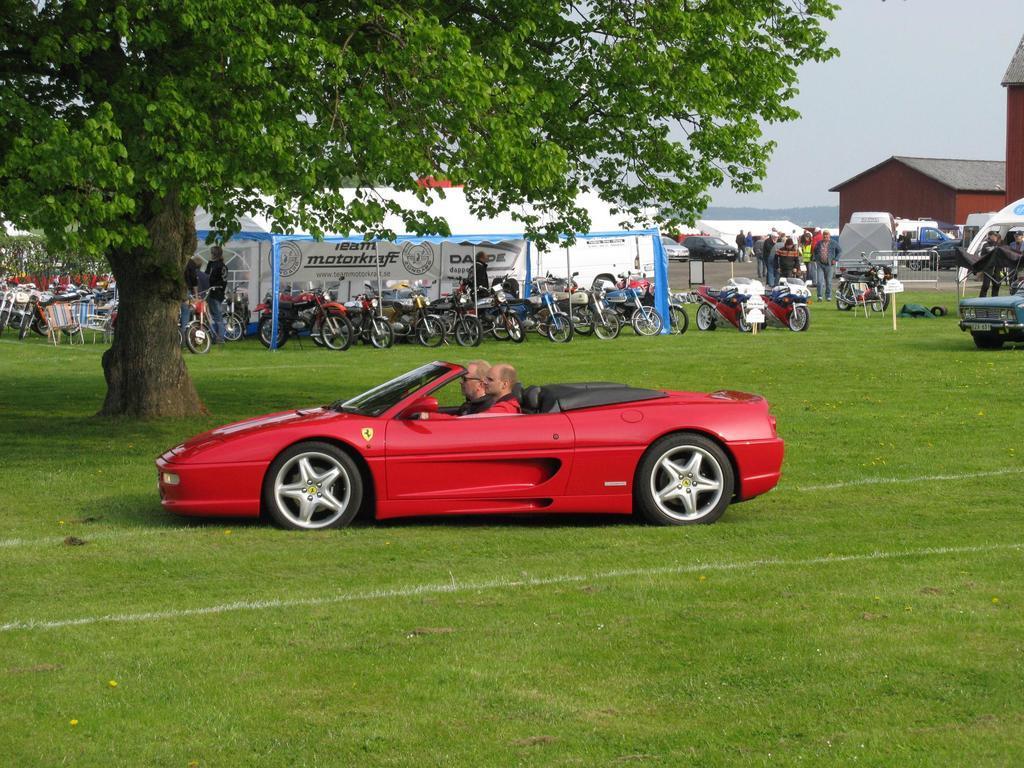Could you give a brief overview of what you see in this image? In this picture there are two men sitting in the red color Ferrari car which is parked in the grass field. Behind you can see some bikes are parked under the shed. Behind there is a brown color shed houses, cars are parked and a group of people standing and discussing something. 